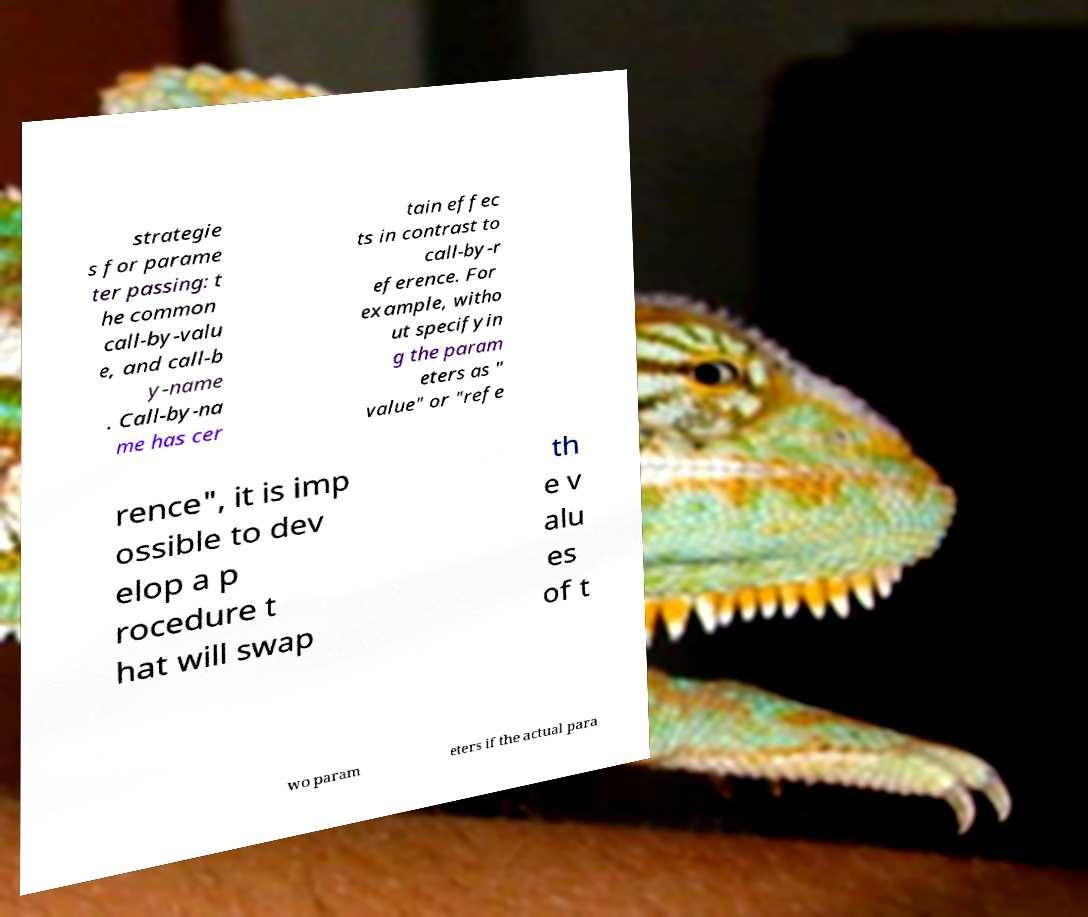There's text embedded in this image that I need extracted. Can you transcribe it verbatim? strategie s for parame ter passing: t he common call-by-valu e, and call-b y-name . Call-by-na me has cer tain effec ts in contrast to call-by-r eference. For example, witho ut specifyin g the param eters as " value" or "refe rence", it is imp ossible to dev elop a p rocedure t hat will swap th e v alu es of t wo param eters if the actual para 